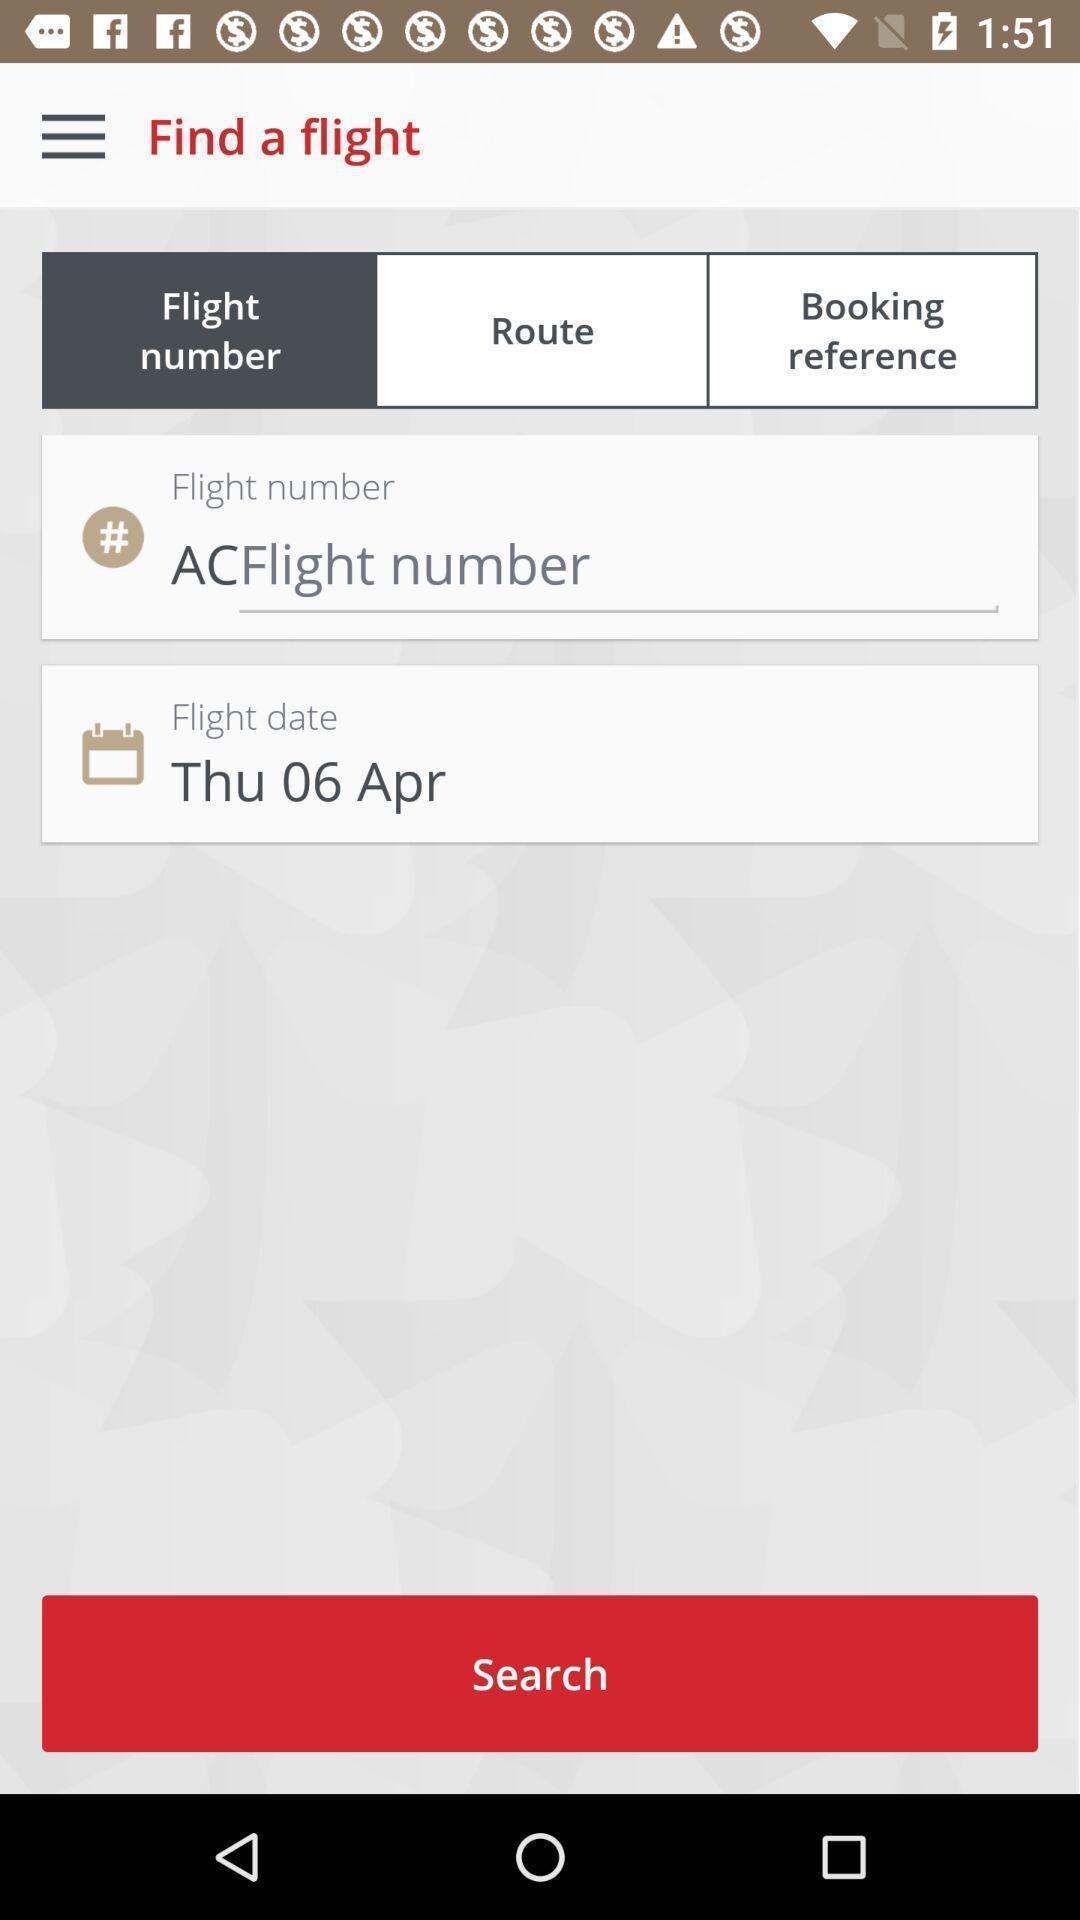Explain the elements present in this screenshot. Search page. 